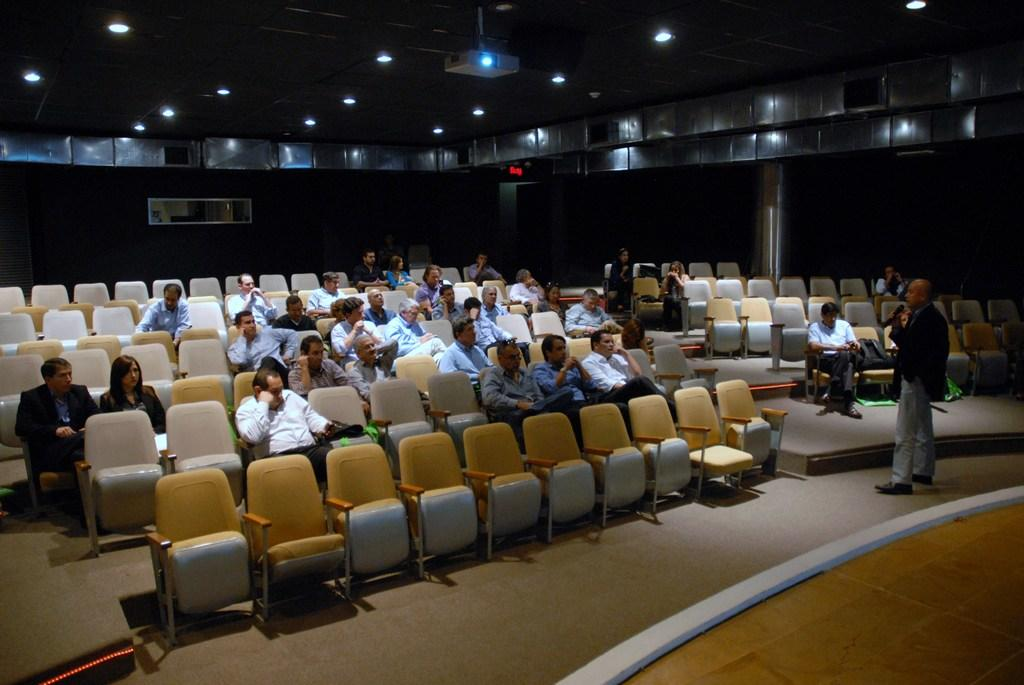What are the people in the image doing? There is a group of people sitting on chairs in the image. Can you describe the person who is standing? One person is standing and wearing a black blazer and gray pants. What can be seen in the background of the image? There are glass windows and lights visible in the background of the image. What type of writer is sitting at the table in the image? There is no writer or table present in the image; it features a group of people sitting on chairs and a standing person. What noise can be heard coming from the people in the image? The image does not provide any information about the sounds or noises in the scene, so it cannot be determined from the image. 